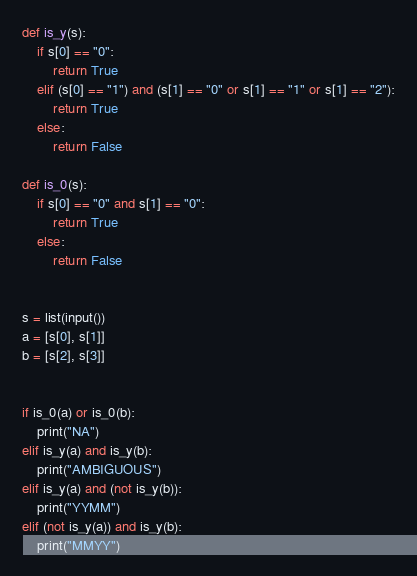<code> <loc_0><loc_0><loc_500><loc_500><_Python_>def is_y(s):
    if s[0] == "0":
        return True
    elif (s[0] == "1") and (s[1] == "0" or s[1] == "1" or s[1] == "2"):
        return True
    else:
        return False

def is_0(s):
    if s[0] == "0" and s[1] == "0":
        return True
    else:
        return False


s = list(input())
a = [s[0], s[1]]
b = [s[2], s[3]]


if is_0(a) or is_0(b):
    print("NA")
elif is_y(a) and is_y(b):
    print("AMBIGUOUS")
elif is_y(a) and (not is_y(b)):
    print("YYMM")
elif (not is_y(a)) and is_y(b):
    print("MMYY")</code> 